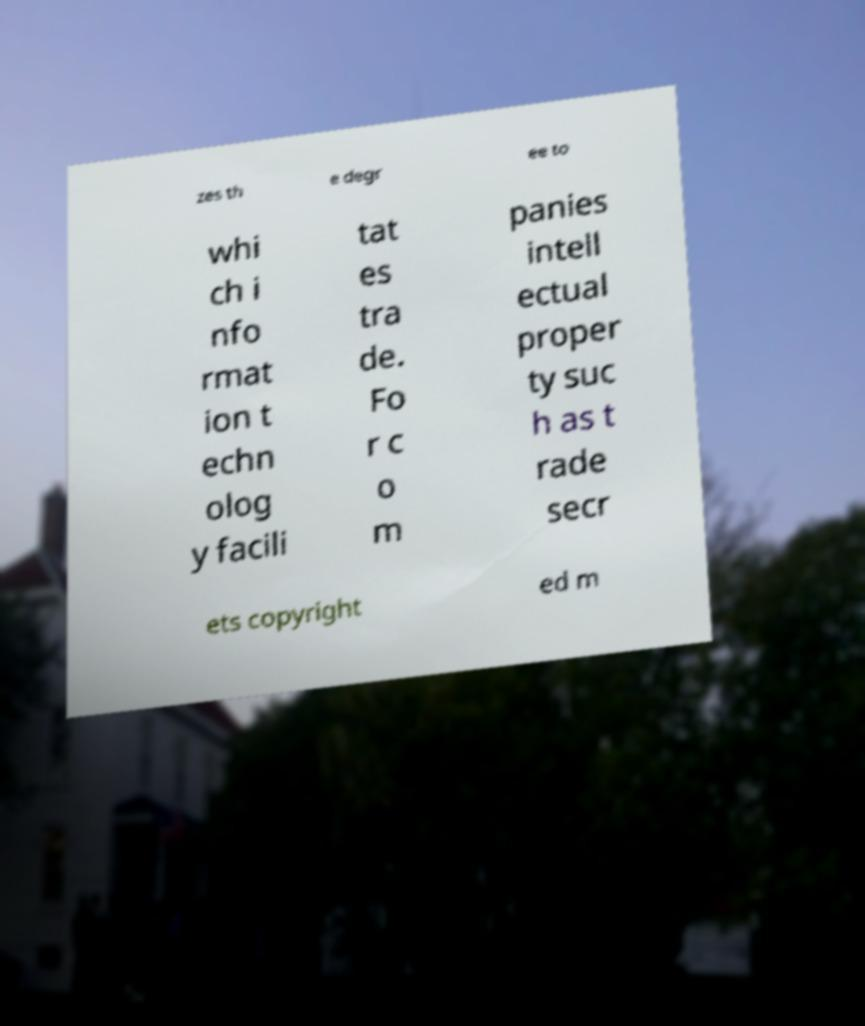What messages or text are displayed in this image? I need them in a readable, typed format. zes th e degr ee to whi ch i nfo rmat ion t echn olog y facili tat es tra de. Fo r c o m panies intell ectual proper ty suc h as t rade secr ets copyright ed m 